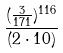Convert formula to latex. <formula><loc_0><loc_0><loc_500><loc_500>\frac { ( \frac { 3 } { 1 7 1 } ) ^ { 1 1 6 } } { ( 2 \cdot 1 0 ) }</formula> 